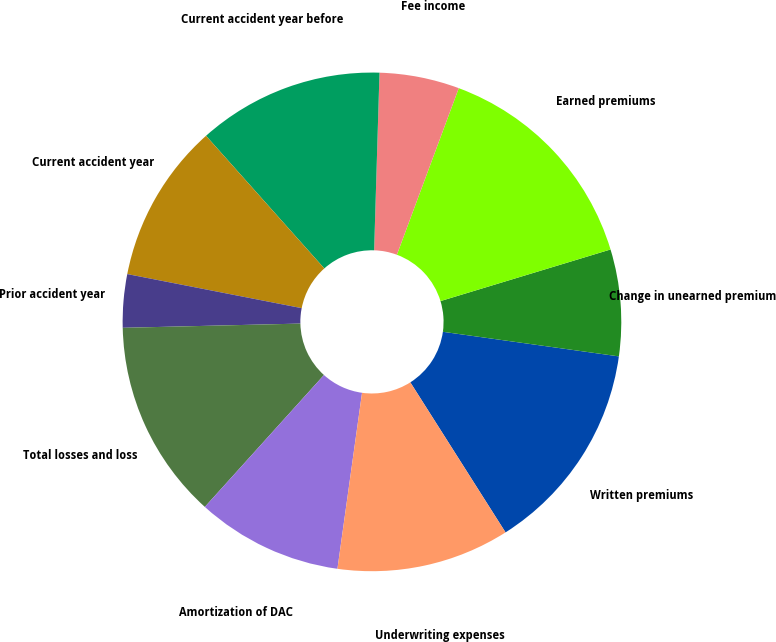Convert chart to OTSL. <chart><loc_0><loc_0><loc_500><loc_500><pie_chart><fcel>Written premiums<fcel>Change in unearned premium<fcel>Earned premiums<fcel>Fee income<fcel>Current accident year before<fcel>Current accident year<fcel>Prior accident year<fcel>Total losses and loss<fcel>Amortization of DAC<fcel>Underwriting expenses<nl><fcel>13.79%<fcel>6.9%<fcel>14.65%<fcel>5.18%<fcel>12.07%<fcel>10.34%<fcel>3.45%<fcel>12.93%<fcel>9.48%<fcel>11.21%<nl></chart> 